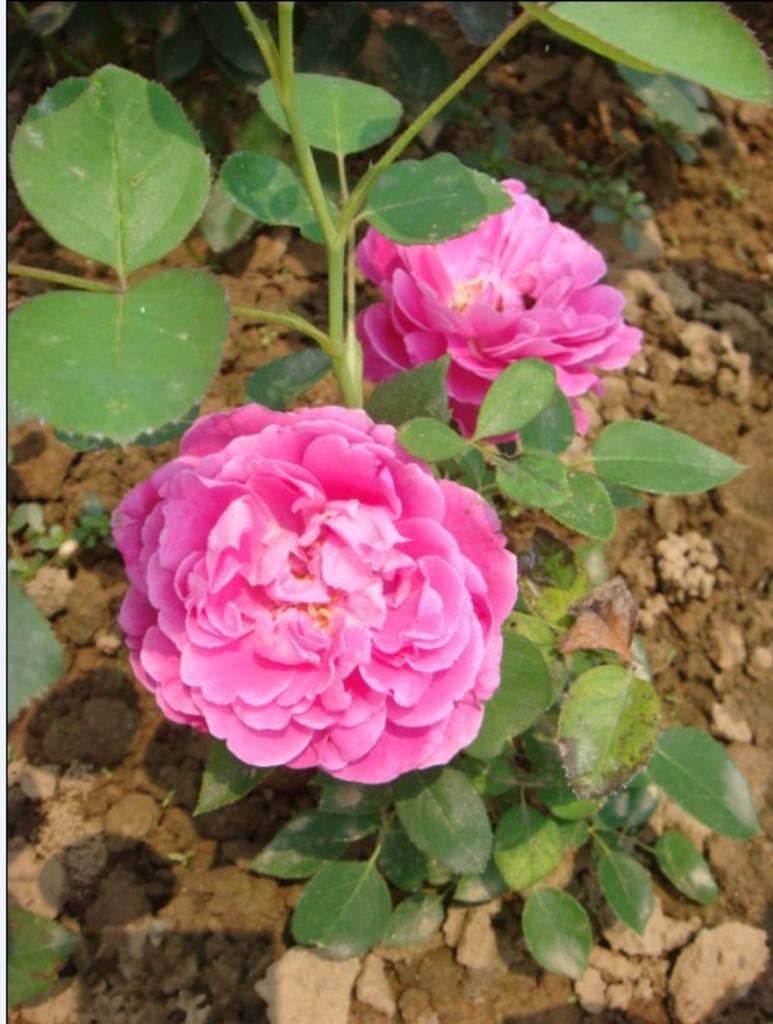In one or two sentences, can you explain what this image depicts? In this image, we can see plants and flowers and at the bottom, there is ground. 